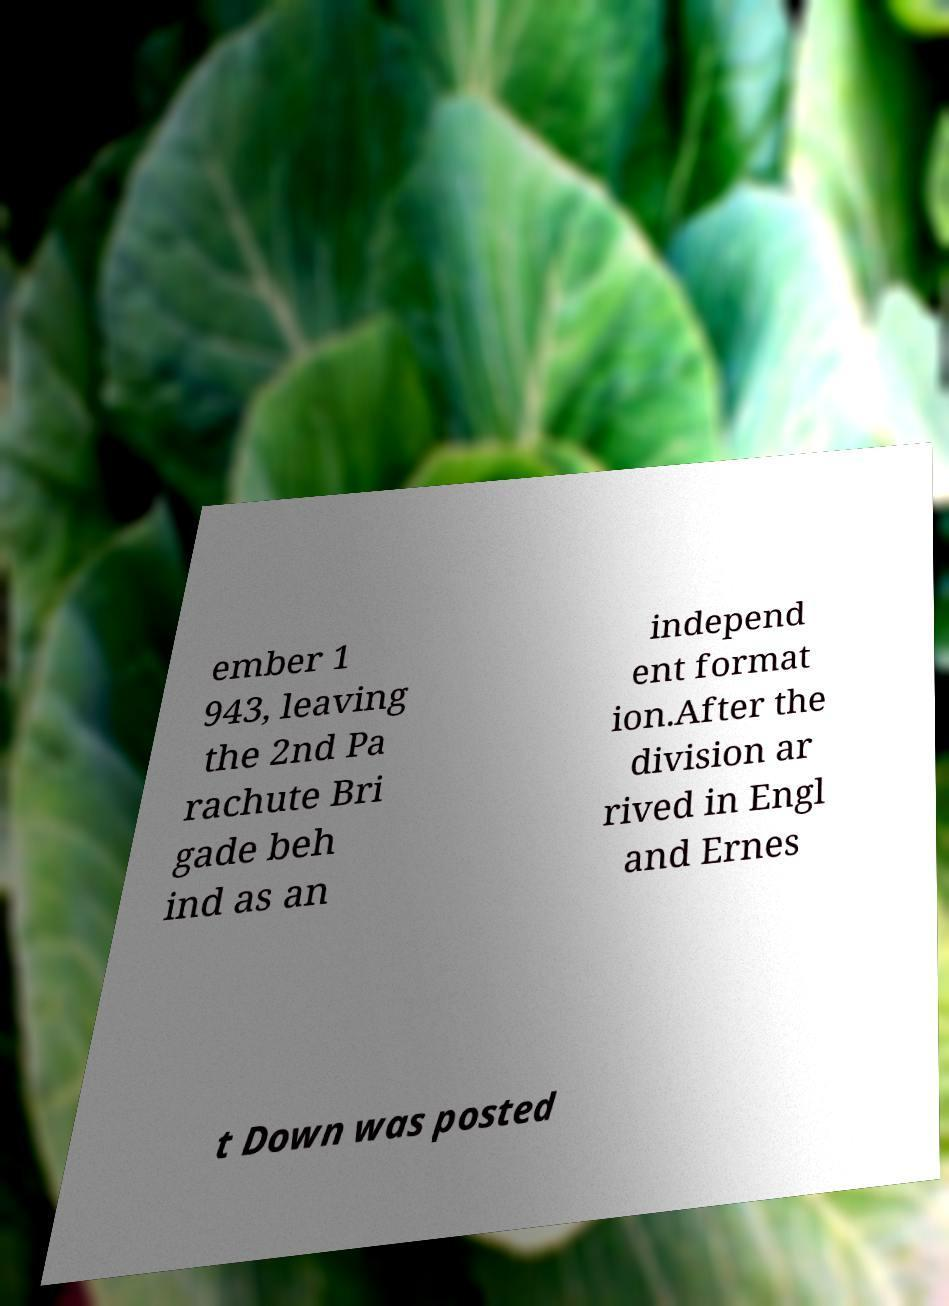Please identify and transcribe the text found in this image. ember 1 943, leaving the 2nd Pa rachute Bri gade beh ind as an independ ent format ion.After the division ar rived in Engl and Ernes t Down was posted 